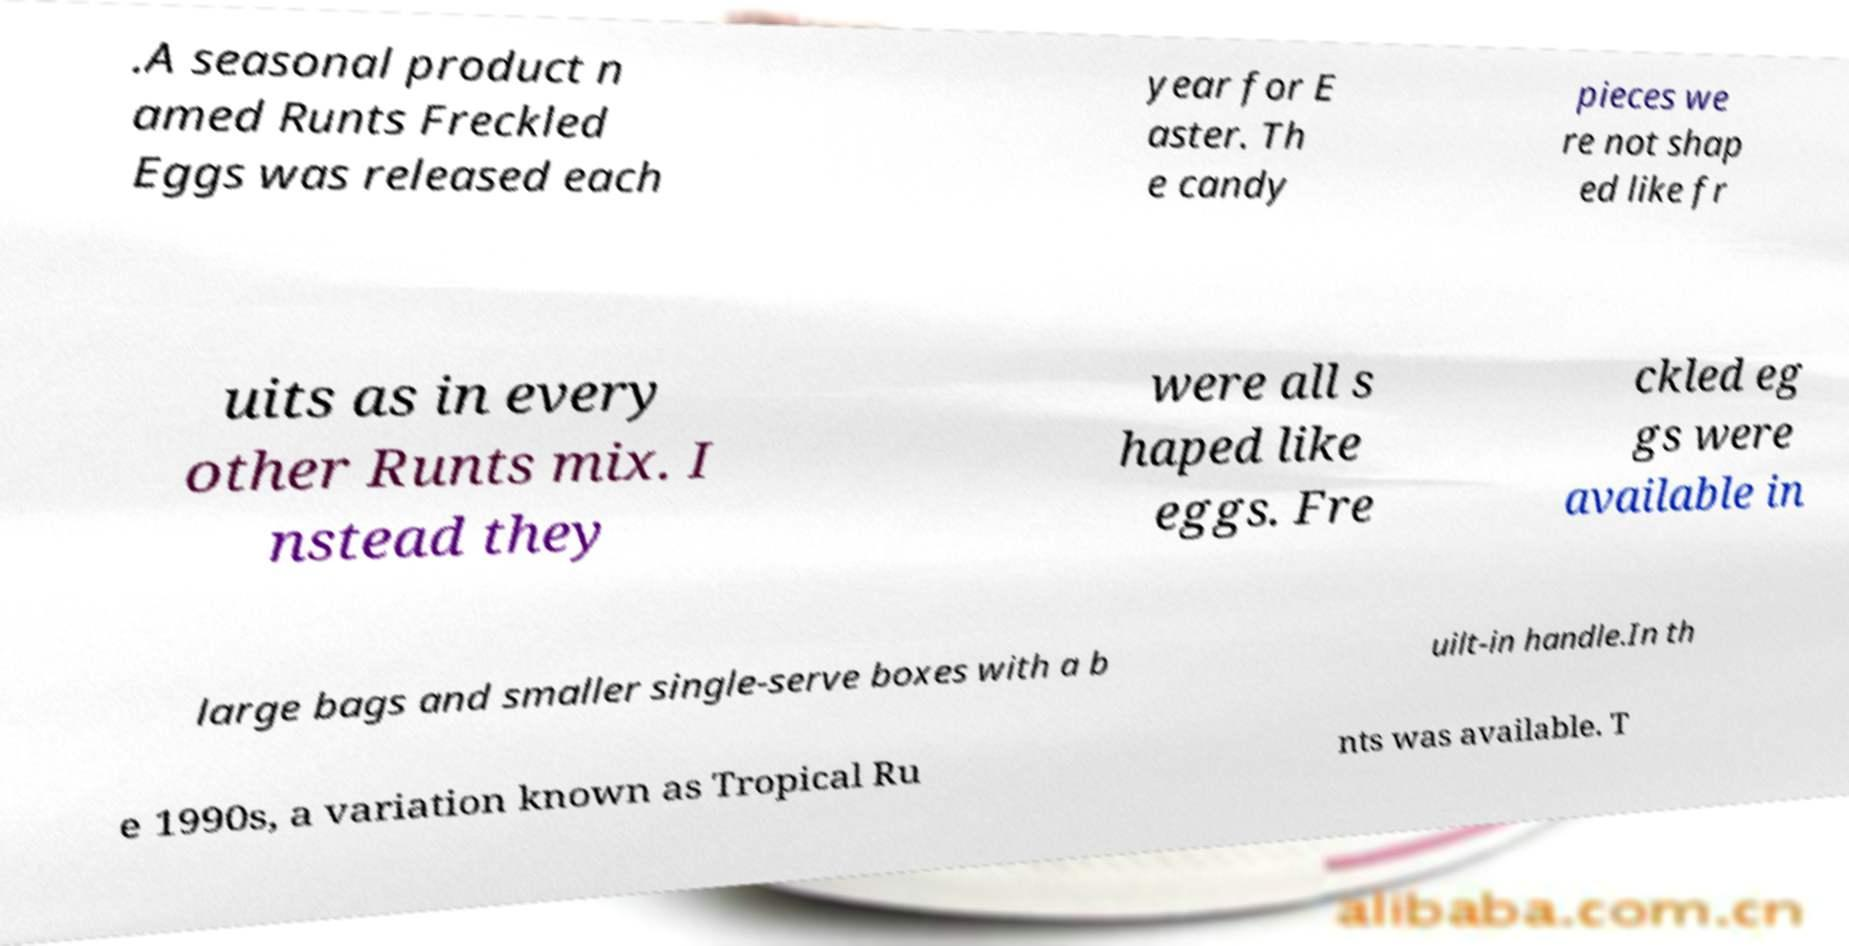What messages or text are displayed in this image? I need them in a readable, typed format. .A seasonal product n amed Runts Freckled Eggs was released each year for E aster. Th e candy pieces we re not shap ed like fr uits as in every other Runts mix. I nstead they were all s haped like eggs. Fre ckled eg gs were available in large bags and smaller single-serve boxes with a b uilt-in handle.In th e 1990s, a variation known as Tropical Ru nts was available. T 